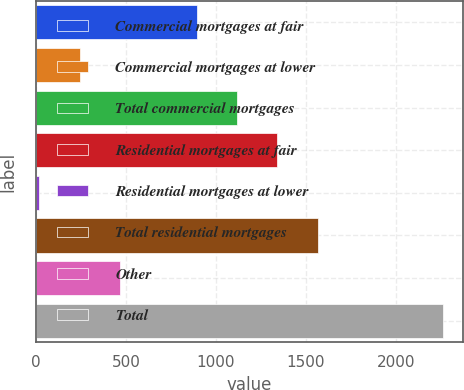<chart> <loc_0><loc_0><loc_500><loc_500><bar_chart><fcel>Commercial mortgages at fair<fcel>Commercial mortgages at lower<fcel>Total commercial mortgages<fcel>Residential mortgages at fair<fcel>Residential mortgages at lower<fcel>Total residential mortgages<fcel>Other<fcel>Total<nl><fcel>893<fcel>242.4<fcel>1117.4<fcel>1341.8<fcel>18<fcel>1566.2<fcel>466.8<fcel>2262<nl></chart> 